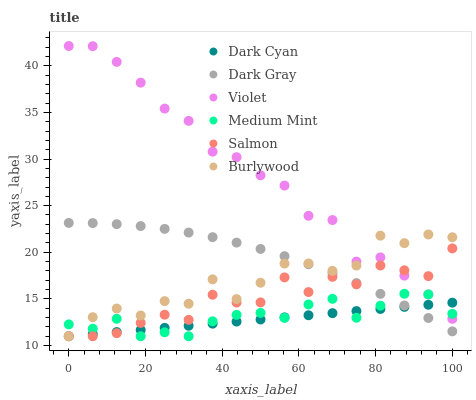Does Dark Cyan have the minimum area under the curve?
Answer yes or no. Yes. Does Violet have the maximum area under the curve?
Answer yes or no. Yes. Does Burlywood have the minimum area under the curve?
Answer yes or no. No. Does Burlywood have the maximum area under the curve?
Answer yes or no. No. Is Dark Cyan the smoothest?
Answer yes or no. Yes. Is Burlywood the roughest?
Answer yes or no. Yes. Is Salmon the smoothest?
Answer yes or no. No. Is Salmon the roughest?
Answer yes or no. No. Does Medium Mint have the lowest value?
Answer yes or no. Yes. Does Dark Gray have the lowest value?
Answer yes or no. No. Does Violet have the highest value?
Answer yes or no. Yes. Does Burlywood have the highest value?
Answer yes or no. No. Is Dark Gray less than Violet?
Answer yes or no. Yes. Is Violet greater than Dark Gray?
Answer yes or no. Yes. Does Dark Gray intersect Burlywood?
Answer yes or no. Yes. Is Dark Gray less than Burlywood?
Answer yes or no. No. Is Dark Gray greater than Burlywood?
Answer yes or no. No. Does Dark Gray intersect Violet?
Answer yes or no. No. 